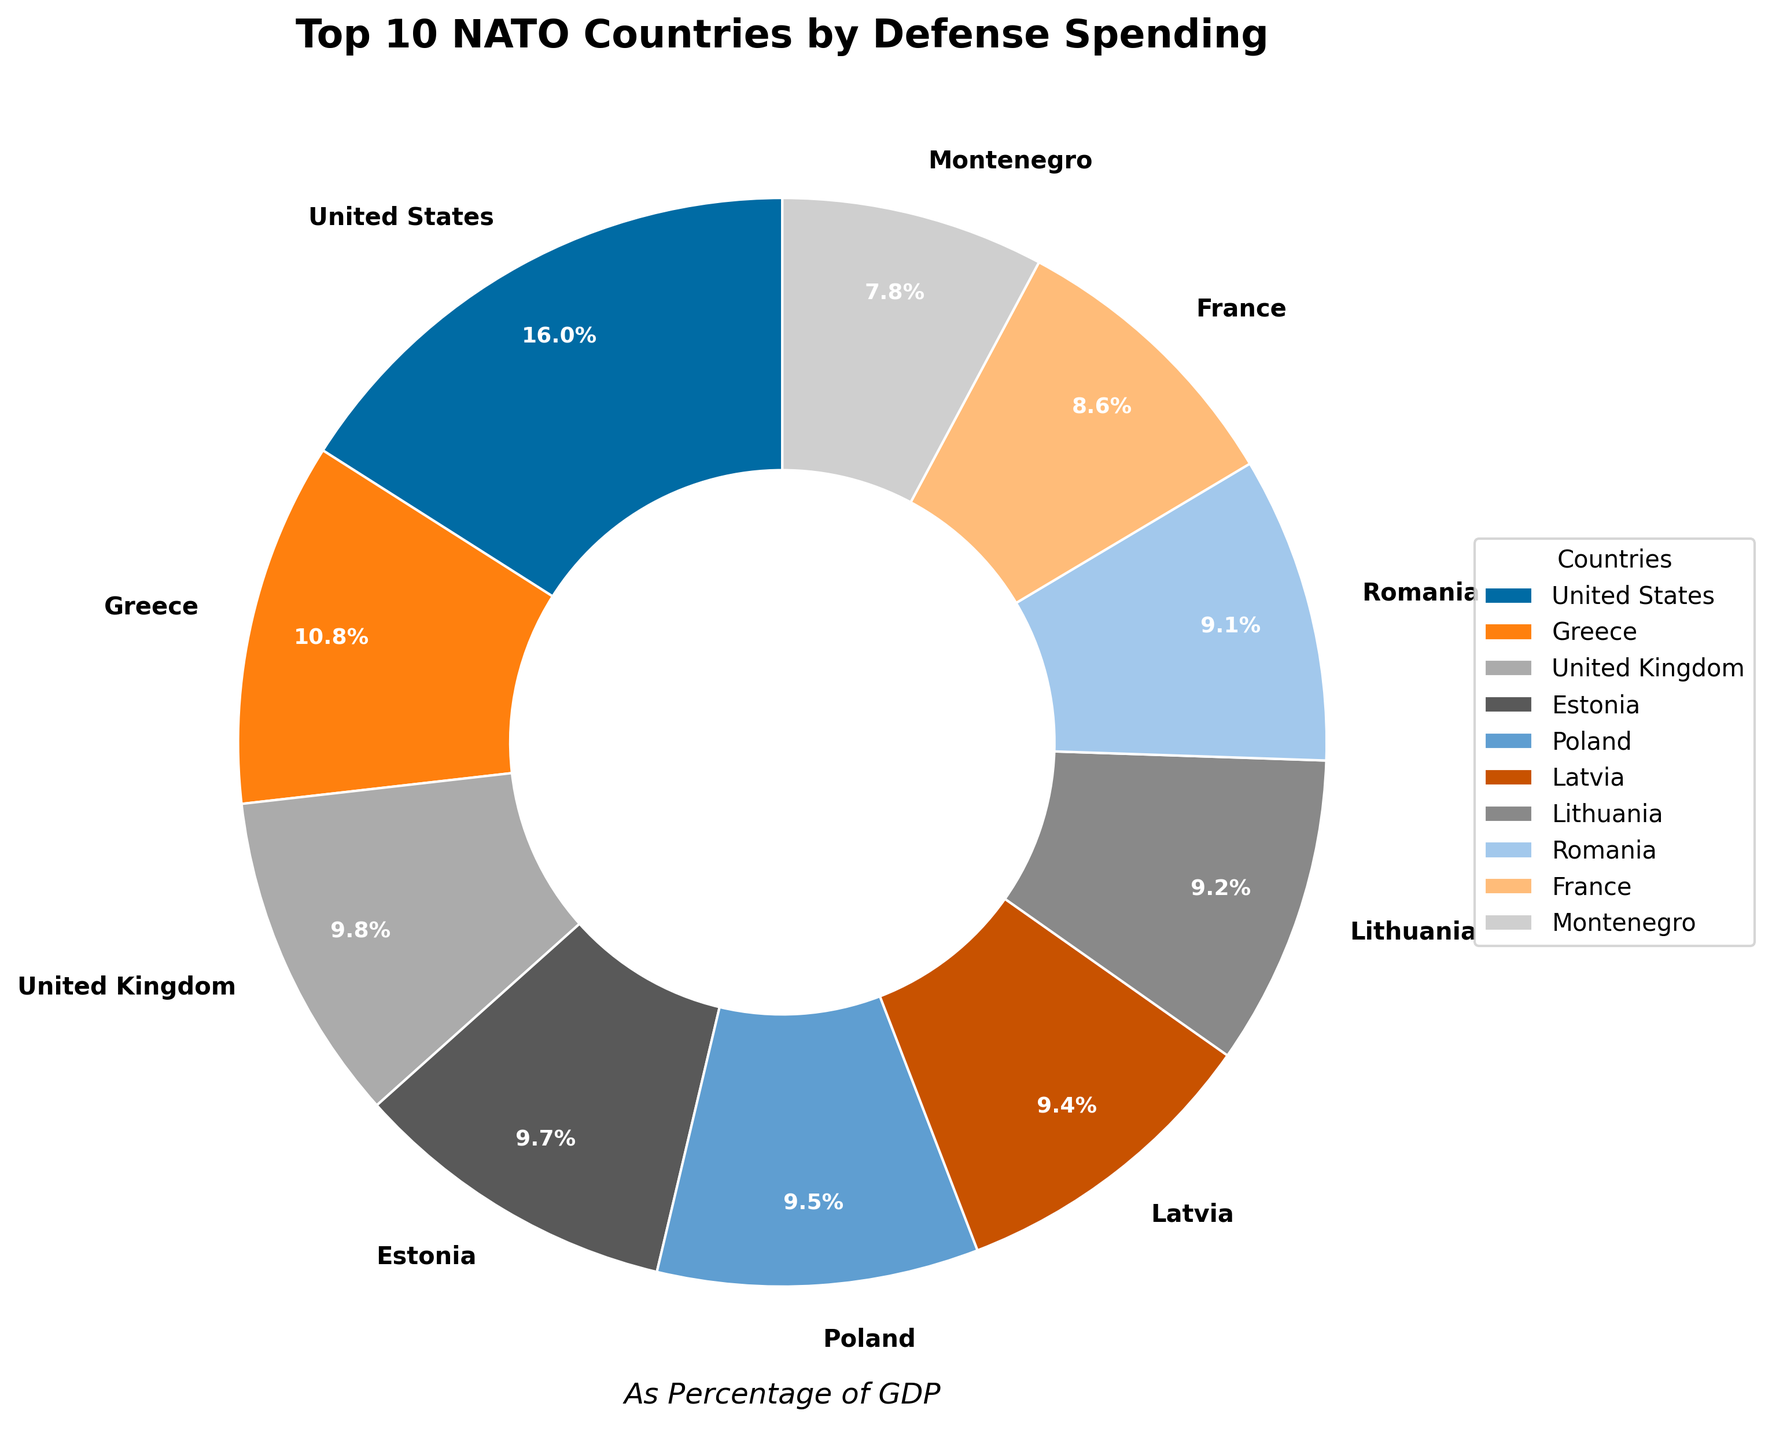What is the country with the highest percentage of GDP spent on defense? Observe the pie chart to determine the country with the largest wedge. The United States has the largest wedge.
Answer: United States How much more does Greece spend as a percentage of GDP on defense compared to Estonia? Identify the slices for Greece and Estonia. Greece's wedge shows 2.38%, and Estonia's shows 2.13%. Subtract the smaller value from the larger one: 2.38% - 2.13% = 0.25%.
Answer: 0.25% Which three countries have the smallest spending percentage among the top 10? Look at the smaller wedges in the pie chart. France, Montenegro, and Croatia have the smallest percentages among the top 10, with values of 1.90%, 1.72%, and 1.68%, respectively.
Answer: France, Montenegro, Croatia What is the total percentage of GDP spent on defense by the top 3 countries combined? Identify the wedges for the United States, Greece, and the United Kingdom. Sum their percentages: 3.52% + 2.38% + 2.16% = 8.06%.
Answer: 8.06% Which country spends just above 2% of its GDP on defense? Look around the 2% mark in the pie chart. Poland has the wedge showing just above 2%, with 2.10%.
Answer: Poland What is the average percentage of GDP spent on defense by the top 10 NATO countries? Identify the percentages for the top 10 countries and sum them up: 3.52% + 2.38% + 2.16% + 2.13% + 2.10% + 2.07% + 2.03% + 2.00% + 1.90% + 1.72%. The total is 22.01%. Divide by the number of countries (10): 22.01% / 10 = 2.201%.
Answer: 2.201% How many countries among the top 10 spend over 2% of their GDP on defense? Identify and count the wedges with values over 2%. The United States, Greece, the United Kingdom, Estonia, Poland, Latvia, and Lithuania have values over 2%. There are 7 countries.
Answer: 7 Which country spends less on defense as a percentage of GDP: Lithuania or Romania? Compare the wedges of Lithuania and Romania. Lithuania's wedge shows 2.03%, and Romania's shows 2.00%. Romania spends less.
Answer: Romania 